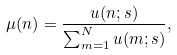<formula> <loc_0><loc_0><loc_500><loc_500>\mu ( n ) = \frac { u ( n ; s ) } { \sum _ { m = 1 } ^ { N } u ( m ; s ) } ,</formula> 